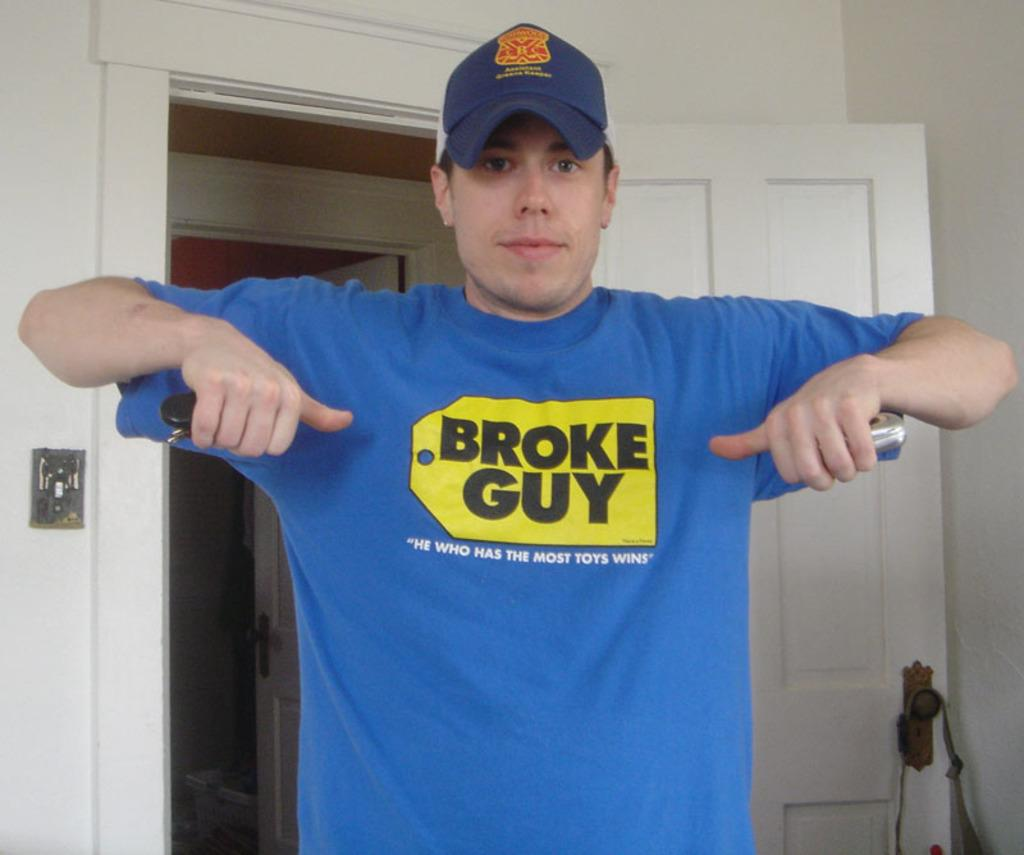<image>
Offer a succinct explanation of the picture presented. A guy in a blue t shirt that says broke guy on it. 